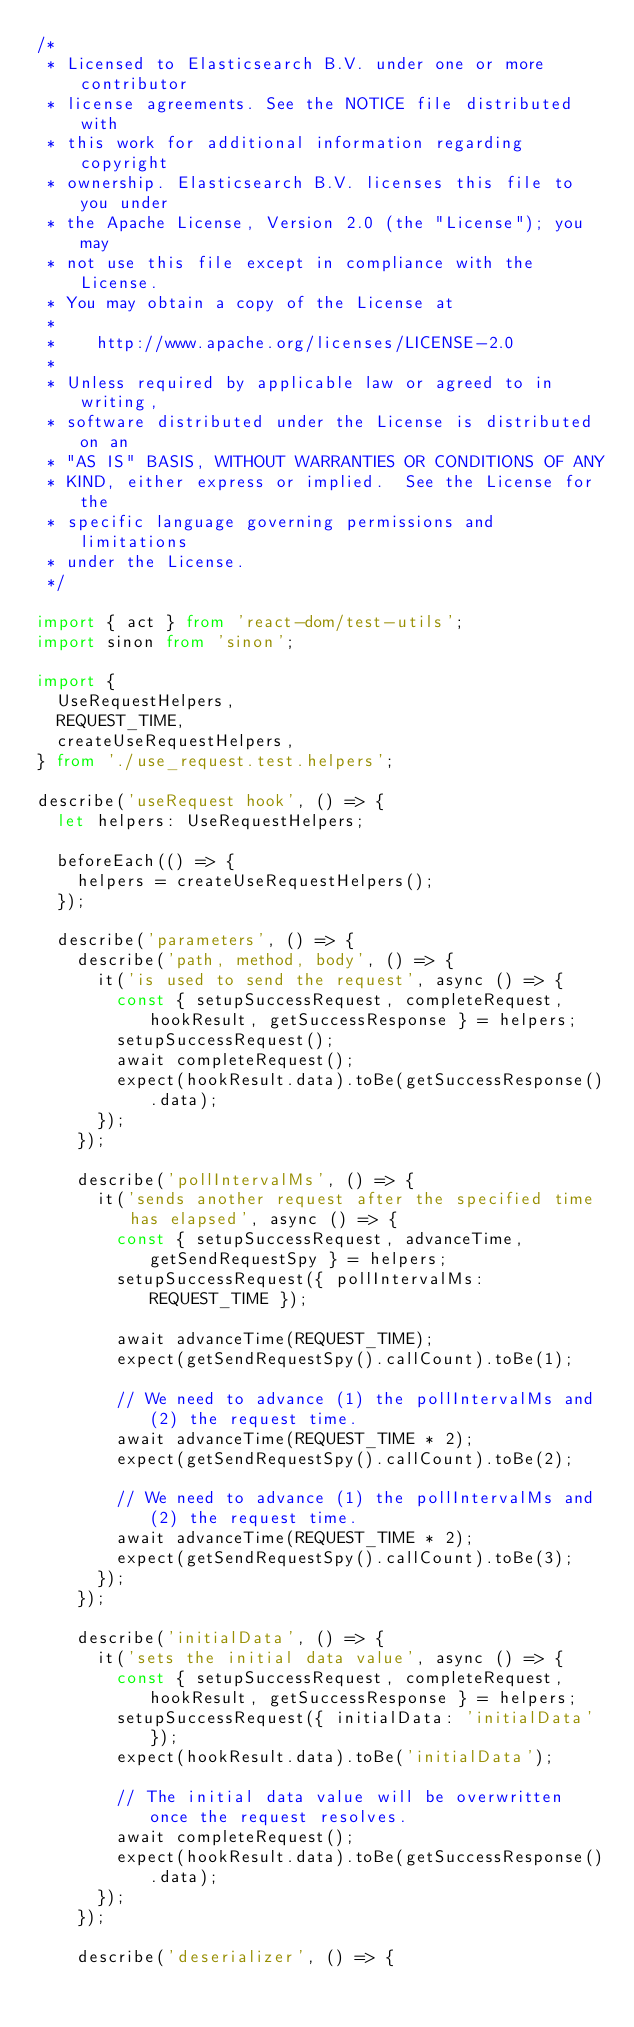<code> <loc_0><loc_0><loc_500><loc_500><_TypeScript_>/*
 * Licensed to Elasticsearch B.V. under one or more contributor
 * license agreements. See the NOTICE file distributed with
 * this work for additional information regarding copyright
 * ownership. Elasticsearch B.V. licenses this file to you under
 * the Apache License, Version 2.0 (the "License"); you may
 * not use this file except in compliance with the License.
 * You may obtain a copy of the License at
 *
 *    http://www.apache.org/licenses/LICENSE-2.0
 *
 * Unless required by applicable law or agreed to in writing,
 * software distributed under the License is distributed on an
 * "AS IS" BASIS, WITHOUT WARRANTIES OR CONDITIONS OF ANY
 * KIND, either express or implied.  See the License for the
 * specific language governing permissions and limitations
 * under the License.
 */

import { act } from 'react-dom/test-utils';
import sinon from 'sinon';

import {
  UseRequestHelpers,
  REQUEST_TIME,
  createUseRequestHelpers,
} from './use_request.test.helpers';

describe('useRequest hook', () => {
  let helpers: UseRequestHelpers;

  beforeEach(() => {
    helpers = createUseRequestHelpers();
  });

  describe('parameters', () => {
    describe('path, method, body', () => {
      it('is used to send the request', async () => {
        const { setupSuccessRequest, completeRequest, hookResult, getSuccessResponse } = helpers;
        setupSuccessRequest();
        await completeRequest();
        expect(hookResult.data).toBe(getSuccessResponse().data);
      });
    });

    describe('pollIntervalMs', () => {
      it('sends another request after the specified time has elapsed', async () => {
        const { setupSuccessRequest, advanceTime, getSendRequestSpy } = helpers;
        setupSuccessRequest({ pollIntervalMs: REQUEST_TIME });

        await advanceTime(REQUEST_TIME);
        expect(getSendRequestSpy().callCount).toBe(1);

        // We need to advance (1) the pollIntervalMs and (2) the request time.
        await advanceTime(REQUEST_TIME * 2);
        expect(getSendRequestSpy().callCount).toBe(2);

        // We need to advance (1) the pollIntervalMs and (2) the request time.
        await advanceTime(REQUEST_TIME * 2);
        expect(getSendRequestSpy().callCount).toBe(3);
      });
    });

    describe('initialData', () => {
      it('sets the initial data value', async () => {
        const { setupSuccessRequest, completeRequest, hookResult, getSuccessResponse } = helpers;
        setupSuccessRequest({ initialData: 'initialData' });
        expect(hookResult.data).toBe('initialData');

        // The initial data value will be overwritten once the request resolves.
        await completeRequest();
        expect(hookResult.data).toBe(getSuccessResponse().data);
      });
    });

    describe('deserializer', () => {</code> 